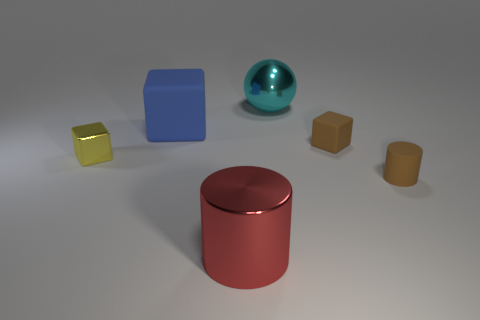Subtract 1 blocks. How many blocks are left? 2 Add 2 big blue blocks. How many objects exist? 8 Subtract all yellow cylinders. Subtract all green spheres. How many cylinders are left? 2 Subtract all cylinders. How many objects are left? 4 Add 6 small brown cylinders. How many small brown cylinders exist? 7 Subtract 0 green spheres. How many objects are left? 6 Subtract all large brown matte cubes. Subtract all tiny shiny cubes. How many objects are left? 5 Add 1 blue matte cubes. How many blue matte cubes are left? 2 